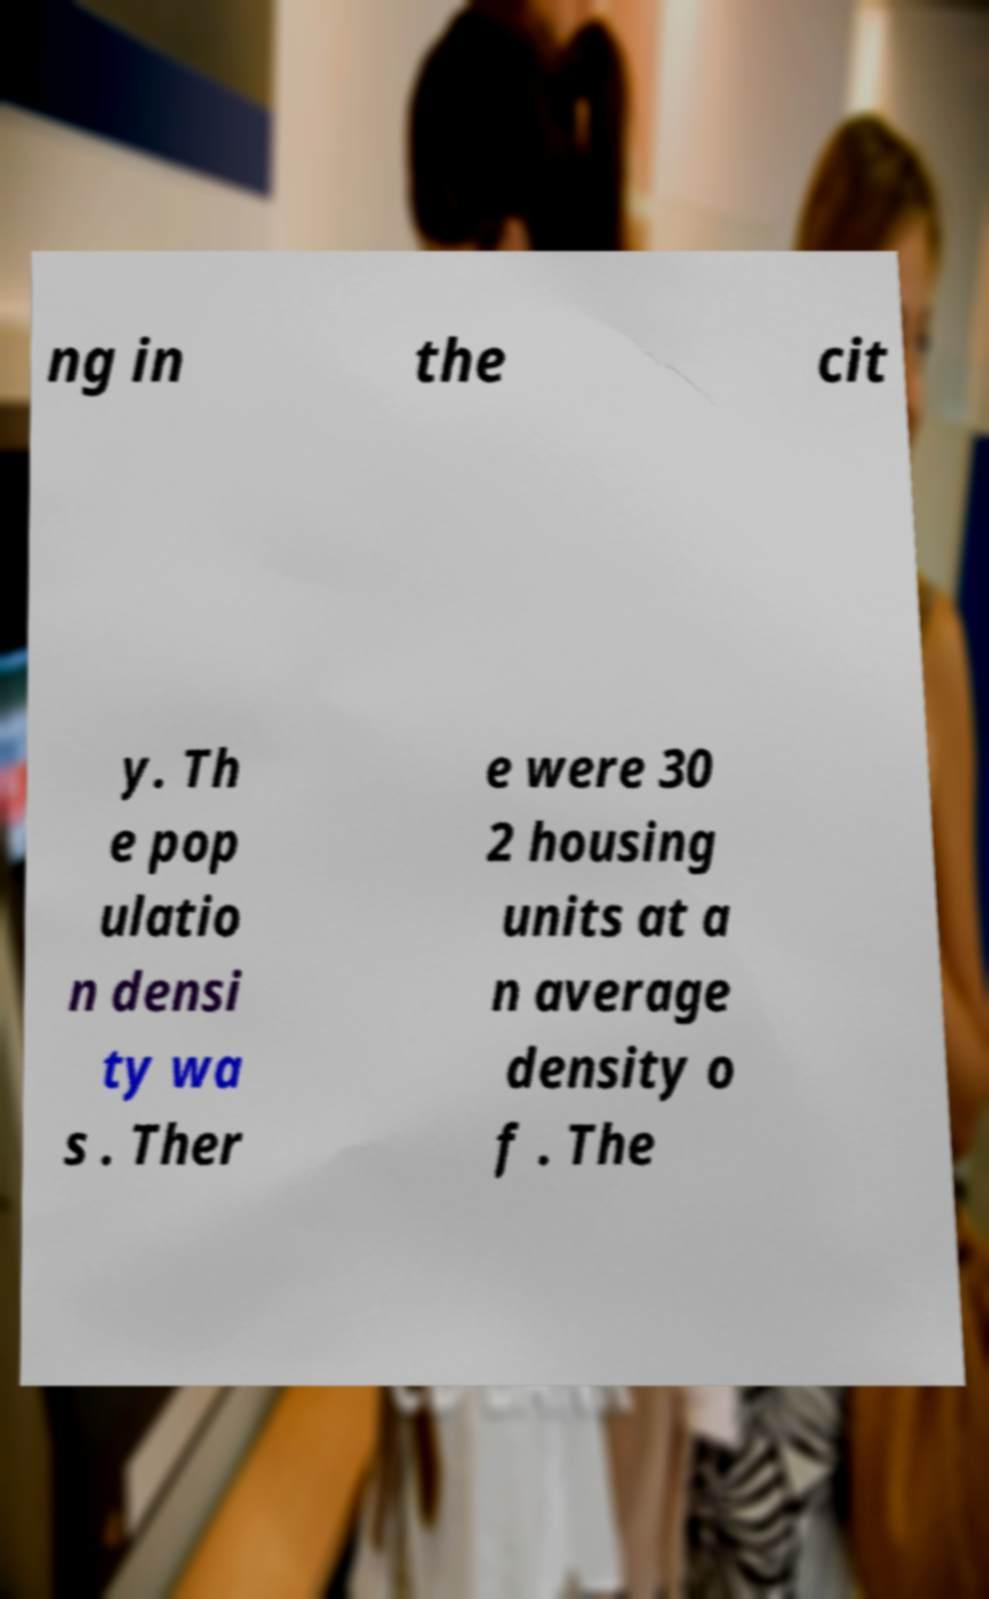Could you extract and type out the text from this image? ng in the cit y. Th e pop ulatio n densi ty wa s . Ther e were 30 2 housing units at a n average density o f . The 